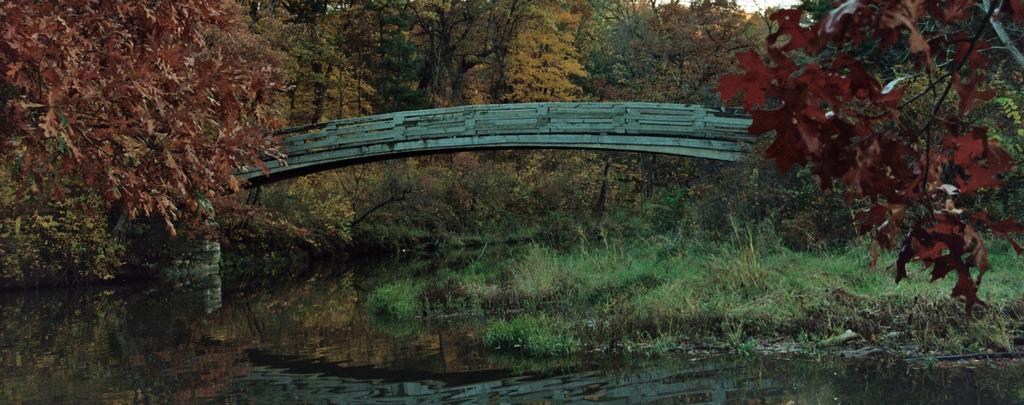What colors can be seen on the trees in the image? The trees in the image have brown, green, and yellow colors. What type of structure is present in the image? There is a bridge in the image. What is visible in the image besides the trees and bridge? There is water and green grass visible in the image. What type of pot is used to adjust the jail's temperature in the image? There is no pot, adjustment, or jail present in the image. 